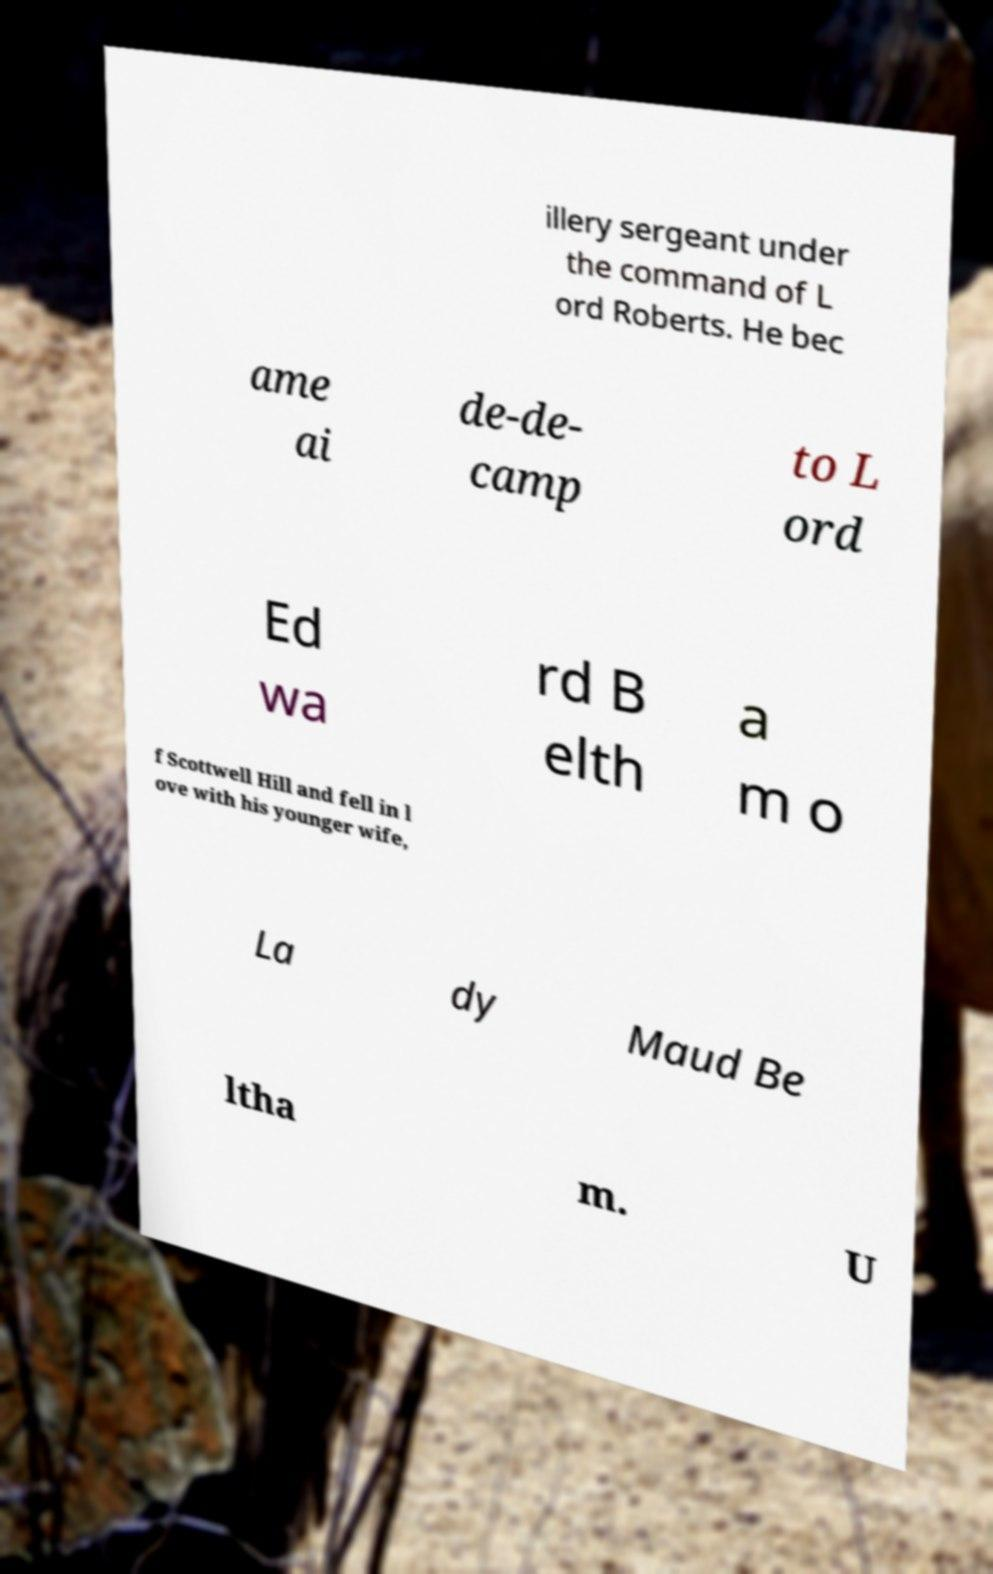There's text embedded in this image that I need extracted. Can you transcribe it verbatim? illery sergeant under the command of L ord Roberts. He bec ame ai de-de- camp to L ord Ed wa rd B elth a m o f Scottwell Hill and fell in l ove with his younger wife, La dy Maud Be ltha m. U 